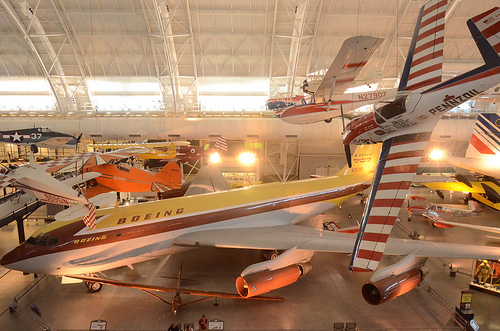<image>
Is the airplane under the ceiling? Yes. The airplane is positioned underneath the ceiling, with the ceiling above it in the vertical space. 